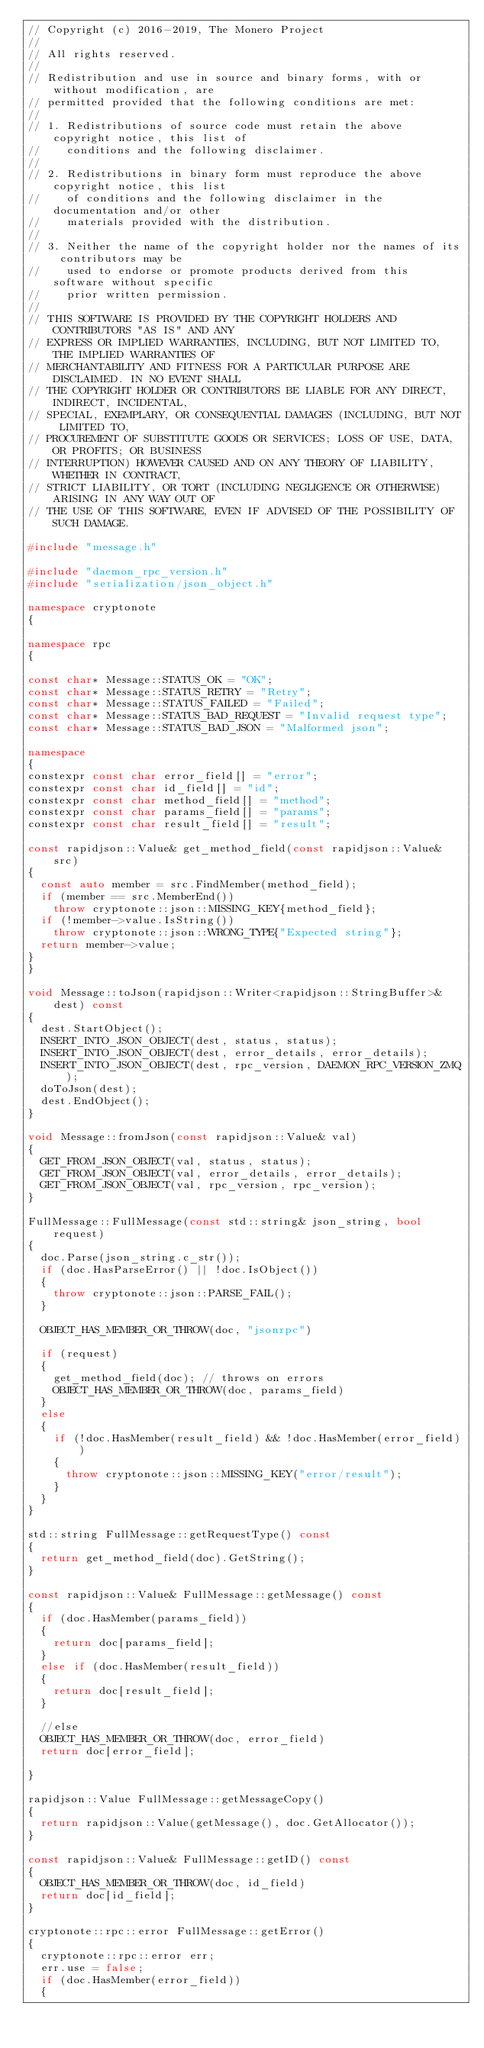<code> <loc_0><loc_0><loc_500><loc_500><_C++_>// Copyright (c) 2016-2019, The Monero Project
//
// All rights reserved.
//
// Redistribution and use in source and binary forms, with or without modification, are
// permitted provided that the following conditions are met:
//
// 1. Redistributions of source code must retain the above copyright notice, this list of
//    conditions and the following disclaimer.
//
// 2. Redistributions in binary form must reproduce the above copyright notice, this list
//    of conditions and the following disclaimer in the documentation and/or other
//    materials provided with the distribution.
//
// 3. Neither the name of the copyright holder nor the names of its contributors may be
//    used to endorse or promote products derived from this software without specific
//    prior written permission.
//
// THIS SOFTWARE IS PROVIDED BY THE COPYRIGHT HOLDERS AND CONTRIBUTORS "AS IS" AND ANY
// EXPRESS OR IMPLIED WARRANTIES, INCLUDING, BUT NOT LIMITED TO, THE IMPLIED WARRANTIES OF
// MERCHANTABILITY AND FITNESS FOR A PARTICULAR PURPOSE ARE DISCLAIMED. IN NO EVENT SHALL
// THE COPYRIGHT HOLDER OR CONTRIBUTORS BE LIABLE FOR ANY DIRECT, INDIRECT, INCIDENTAL,
// SPECIAL, EXEMPLARY, OR CONSEQUENTIAL DAMAGES (INCLUDING, BUT NOT LIMITED TO,
// PROCUREMENT OF SUBSTITUTE GOODS OR SERVICES; LOSS OF USE, DATA, OR PROFITS; OR BUSINESS
// INTERRUPTION) HOWEVER CAUSED AND ON ANY THEORY OF LIABILITY, WHETHER IN CONTRACT,
// STRICT LIABILITY, OR TORT (INCLUDING NEGLIGENCE OR OTHERWISE) ARISING IN ANY WAY OUT OF
// THE USE OF THIS SOFTWARE, EVEN IF ADVISED OF THE POSSIBILITY OF SUCH DAMAGE.

#include "message.h"

#include "daemon_rpc_version.h"
#include "serialization/json_object.h"

namespace cryptonote
{

namespace rpc
{

const char* Message::STATUS_OK = "OK";
const char* Message::STATUS_RETRY = "Retry";
const char* Message::STATUS_FAILED = "Failed";
const char* Message::STATUS_BAD_REQUEST = "Invalid request type";
const char* Message::STATUS_BAD_JSON = "Malformed json";

namespace
{
constexpr const char error_field[] = "error";
constexpr const char id_field[] = "id";
constexpr const char method_field[] = "method";
constexpr const char params_field[] = "params";
constexpr const char result_field[] = "result";

const rapidjson::Value& get_method_field(const rapidjson::Value& src)
{
  const auto member = src.FindMember(method_field);
  if (member == src.MemberEnd())
    throw cryptonote::json::MISSING_KEY{method_field};
  if (!member->value.IsString())
    throw cryptonote::json::WRONG_TYPE{"Expected string"};
  return member->value;
}
}

void Message::toJson(rapidjson::Writer<rapidjson::StringBuffer>& dest) const
{
  dest.StartObject();
  INSERT_INTO_JSON_OBJECT(dest, status, status);
  INSERT_INTO_JSON_OBJECT(dest, error_details, error_details);
  INSERT_INTO_JSON_OBJECT(dest, rpc_version, DAEMON_RPC_VERSION_ZMQ);
  doToJson(dest);
  dest.EndObject();
}

void Message::fromJson(const rapidjson::Value& val)
{
  GET_FROM_JSON_OBJECT(val, status, status);
  GET_FROM_JSON_OBJECT(val, error_details, error_details);
  GET_FROM_JSON_OBJECT(val, rpc_version, rpc_version);
}

FullMessage::FullMessage(const std::string& json_string, bool request)
{
  doc.Parse(json_string.c_str());
  if (doc.HasParseError() || !doc.IsObject())
  {
    throw cryptonote::json::PARSE_FAIL();
  }

  OBJECT_HAS_MEMBER_OR_THROW(doc, "jsonrpc")

  if (request)
  {
    get_method_field(doc); // throws on errors
    OBJECT_HAS_MEMBER_OR_THROW(doc, params_field)
  }
  else
  {
    if (!doc.HasMember(result_field) && !doc.HasMember(error_field))
    {
      throw cryptonote::json::MISSING_KEY("error/result");
    }
  }
}

std::string FullMessage::getRequestType() const
{
  return get_method_field(doc).GetString();
}

const rapidjson::Value& FullMessage::getMessage() const
{
  if (doc.HasMember(params_field))
  {
    return doc[params_field];
  }
  else if (doc.HasMember(result_field))
  {
    return doc[result_field];
  }

  //else
  OBJECT_HAS_MEMBER_OR_THROW(doc, error_field)
  return doc[error_field];

}

rapidjson::Value FullMessage::getMessageCopy()
{
  return rapidjson::Value(getMessage(), doc.GetAllocator());
}

const rapidjson::Value& FullMessage::getID() const
{
  OBJECT_HAS_MEMBER_OR_THROW(doc, id_field)
  return doc[id_field];
}

cryptonote::rpc::error FullMessage::getError()
{
  cryptonote::rpc::error err;
  err.use = false;
  if (doc.HasMember(error_field))
  {</code> 